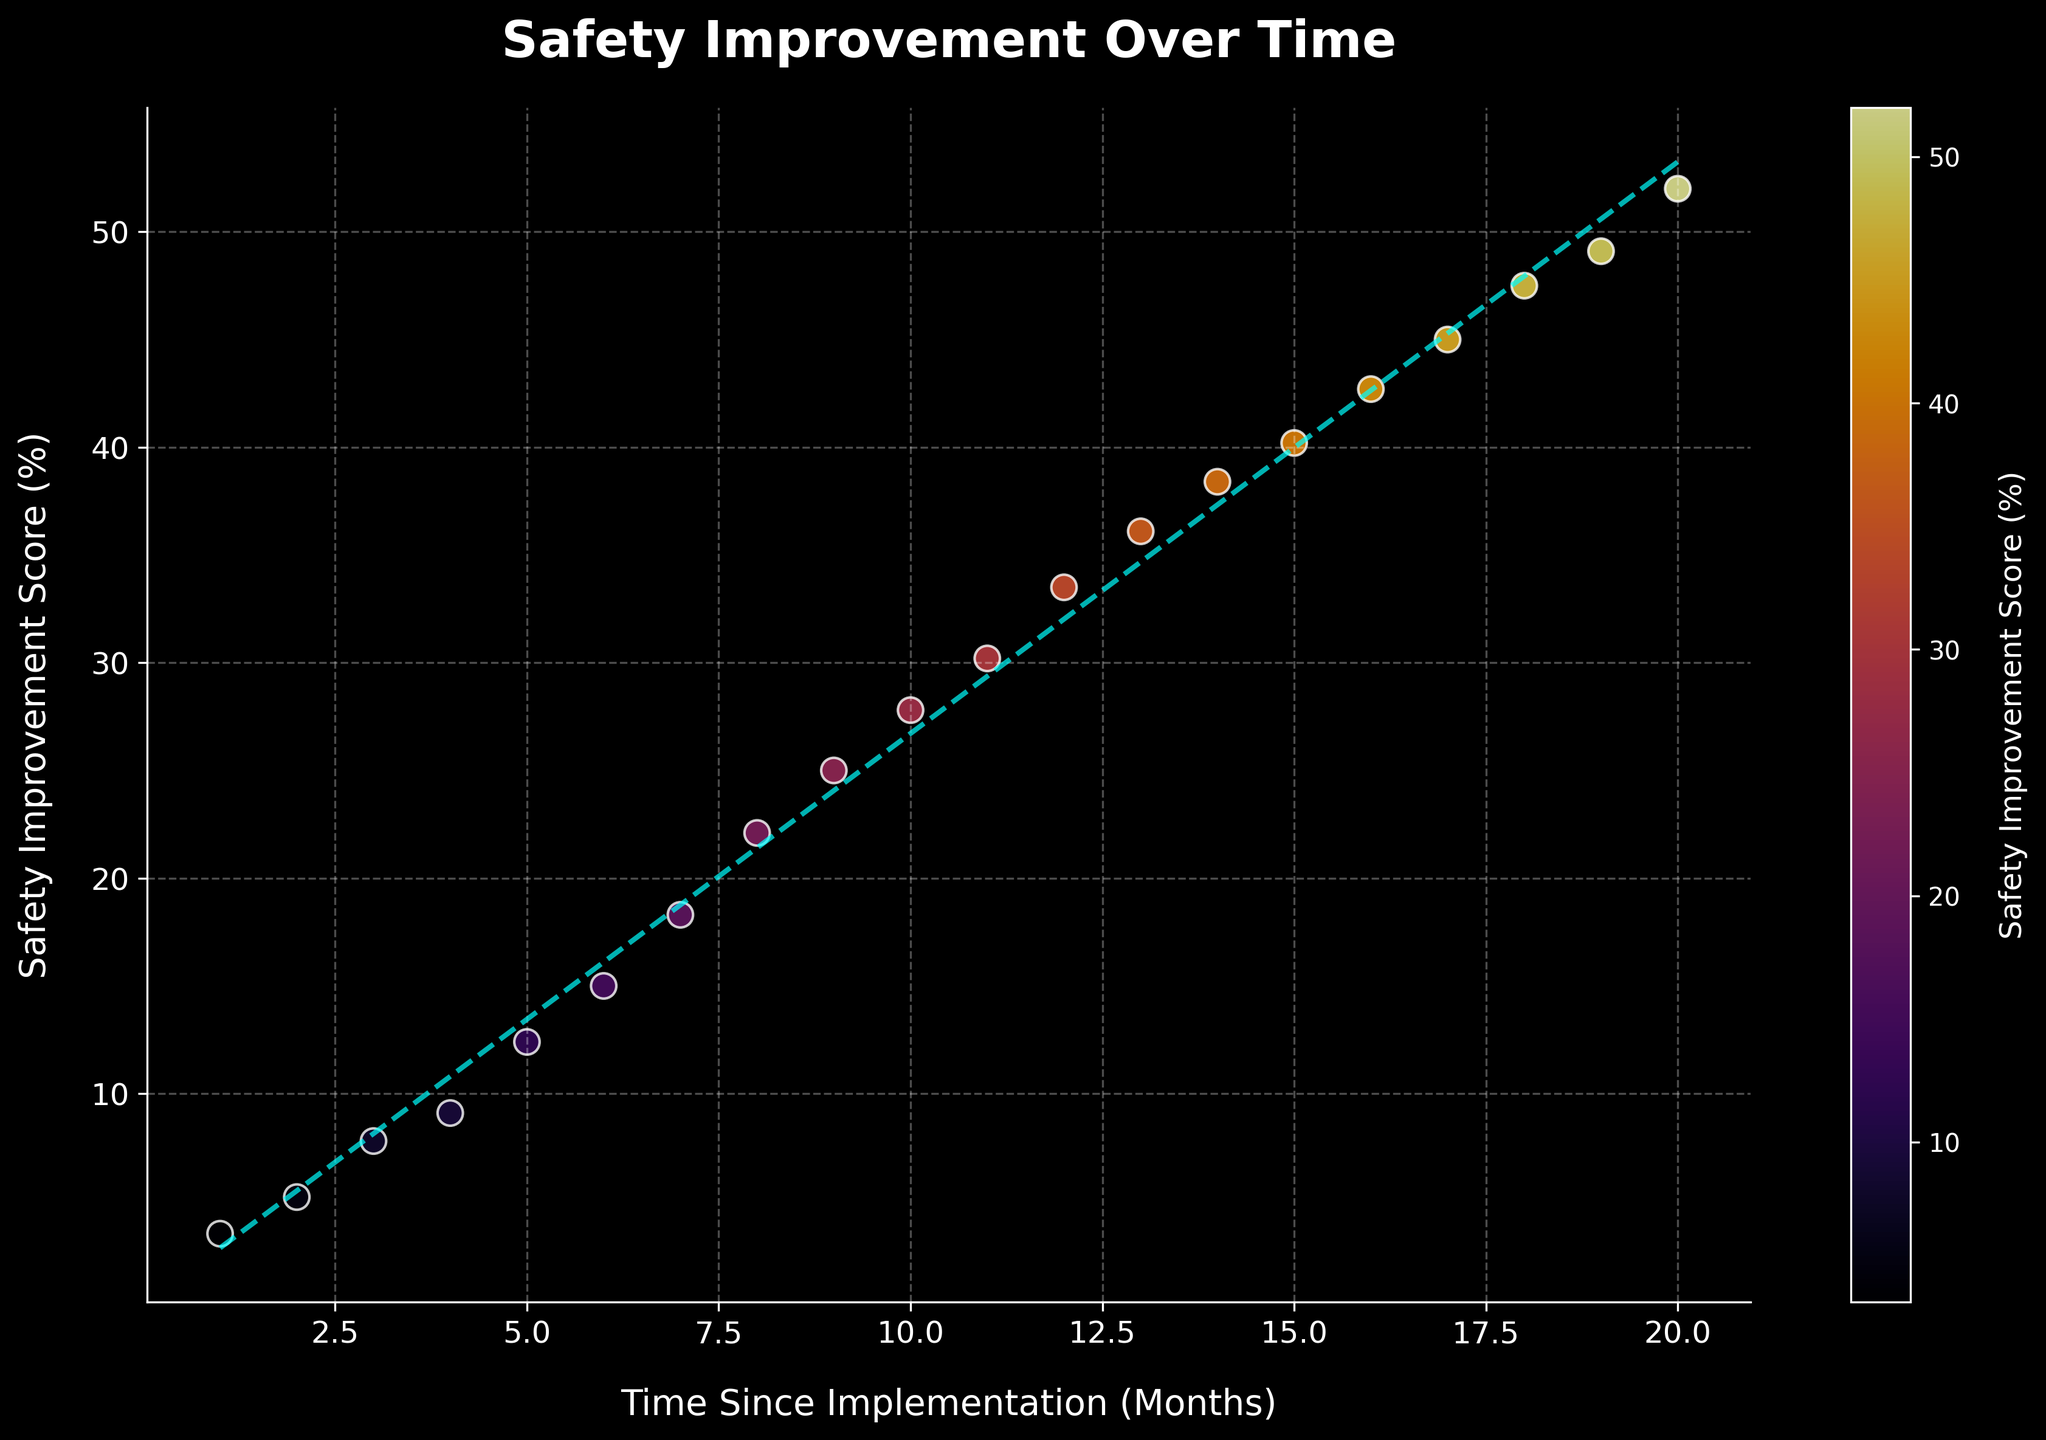What's the title of the scatter plot? The title of the scatter plot is displayed at the top-center of the figure.
Answer: Safety Improvement Over Time What is the x-axis label? The x-axis label can be found under the horizontal axis at the bottom of the figure.
Answer: Time Since Implementation (Months) How many data points are shown in the scatter plot? Count the number of individual points that are marked on the plot. Each point represents a data point.
Answer: 20 Which data point has the highest Safety Improvement Score? The highest Safety Improvement Score is represented by the data point that is plotted at the highest vertical position on the scatter plot.
Answer: The data point at 20 months What are the Safety Improvement Scores at 6 and 12 months? Locate the points corresponding to 6 months and 12 months on the x-axis and read their respective scores on the y-axis.
Answer: 15.0% and 33.5% What is the approximate slope of the trend line? The slope of the trend line can be estimated by looking at how much the y-axis (Safety Improvement Score) changes per unit of the x-axis (Time Since Implementation).
Answer: About 2.5% per month Between which months does the highest increase in Safety Improvement Score occur? Look at the plot and identify the steepest part of the trend line, which indicates the highest rate of change.
Answer: 1 to 2 months Approximately what is the average Safety Improvement Score over the 20-month period? Sum all the y-values (Safety Improvement Scores) and divide by the number of data points. (3.5 + 5.2 + 7.8 + 9.1 + 12.4 + 15.0 + 18.3 + 22.1 + 25.0 + 27.8 + 30.2 + 33.5 + 36.1 + 38.4 + 40.2 + 42.7 + 45.0 + 47.5 + 49.1 + 52.0) / 20 = 27.09
Answer: 27.09% Does the trend line fit the data points well? Assess how closely the data points align with the trend line; a good fit would mean most points lie near or on the line.
Answer: Yes, it fits well At which month does the Safety Improvement Score surpass 30%? Find the point where the y-axis value exceeds 30%, and read the corresponding x-axis (months).
Answer: 11 months 